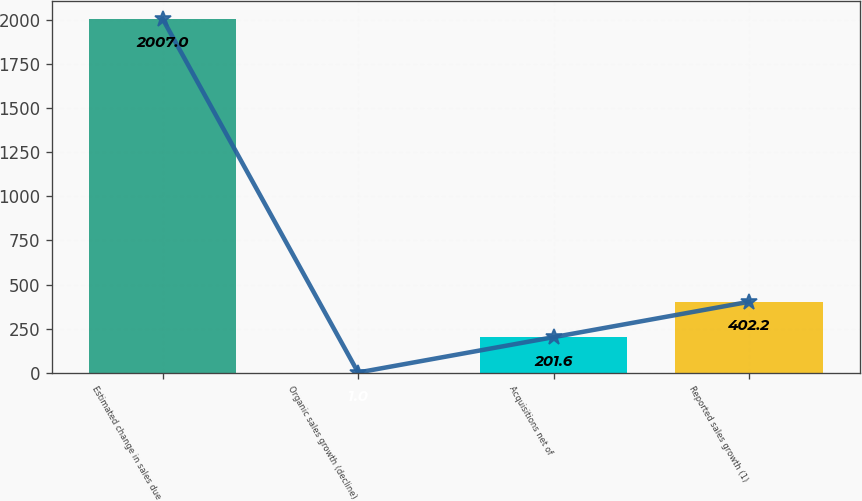Convert chart. <chart><loc_0><loc_0><loc_500><loc_500><bar_chart><fcel>Estimated change in sales due<fcel>Organic sales growth (decline)<fcel>Acquisitions net of<fcel>Reported sales growth (1)<nl><fcel>2007<fcel>1<fcel>201.6<fcel>402.2<nl></chart> 